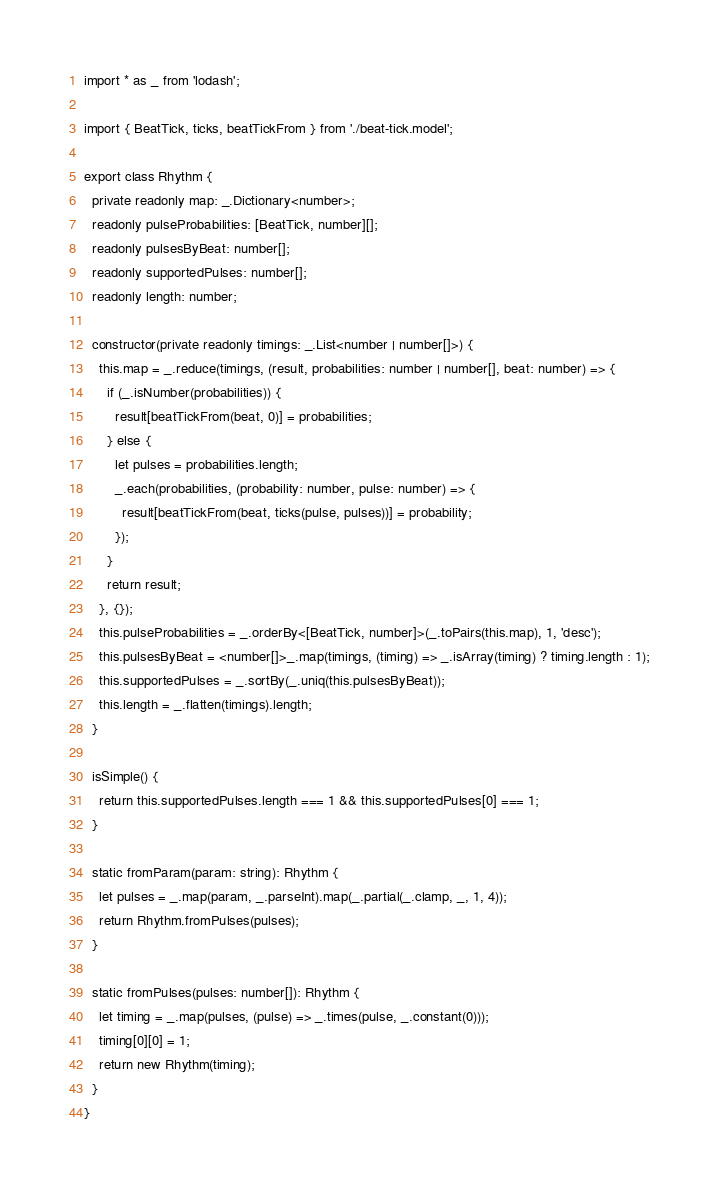<code> <loc_0><loc_0><loc_500><loc_500><_TypeScript_>import * as _ from 'lodash';

import { BeatTick, ticks, beatTickFrom } from './beat-tick.model';

export class Rhythm {
  private readonly map: _.Dictionary<number>;
  readonly pulseProbabilities: [BeatTick, number][];
  readonly pulsesByBeat: number[];
  readonly supportedPulses: number[];
  readonly length: number;

  constructor(private readonly timings: _.List<number | number[]>) {
    this.map = _.reduce(timings, (result, probabilities: number | number[], beat: number) => {
      if (_.isNumber(probabilities)) {
        result[beatTickFrom(beat, 0)] = probabilities;
      } else {
        let pulses = probabilities.length;
        _.each(probabilities, (probability: number, pulse: number) => {
          result[beatTickFrom(beat, ticks(pulse, pulses))] = probability;
        });
      }
      return result;
    }, {});
    this.pulseProbabilities = _.orderBy<[BeatTick, number]>(_.toPairs(this.map), 1, 'desc');
    this.pulsesByBeat = <number[]>_.map(timings, (timing) => _.isArray(timing) ? timing.length : 1);
    this.supportedPulses = _.sortBy(_.uniq(this.pulsesByBeat));
    this.length = _.flatten(timings).length;
  }

  isSimple() {
    return this.supportedPulses.length === 1 && this.supportedPulses[0] === 1;
  }

  static fromParam(param: string): Rhythm {
    let pulses = _.map(param, _.parseInt).map(_.partial(_.clamp, _, 1, 4));
    return Rhythm.fromPulses(pulses);
  }

  static fromPulses(pulses: number[]): Rhythm {
    let timing = _.map(pulses, (pulse) => _.times(pulse, _.constant(0)));
    timing[0][0] = 1;
    return new Rhythm(timing);
  }
}
</code> 